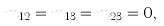<formula> <loc_0><loc_0><loc_500><loc_500>m _ { 1 2 } = m _ { 1 3 } = m _ { 2 3 } = 0 ,</formula> 